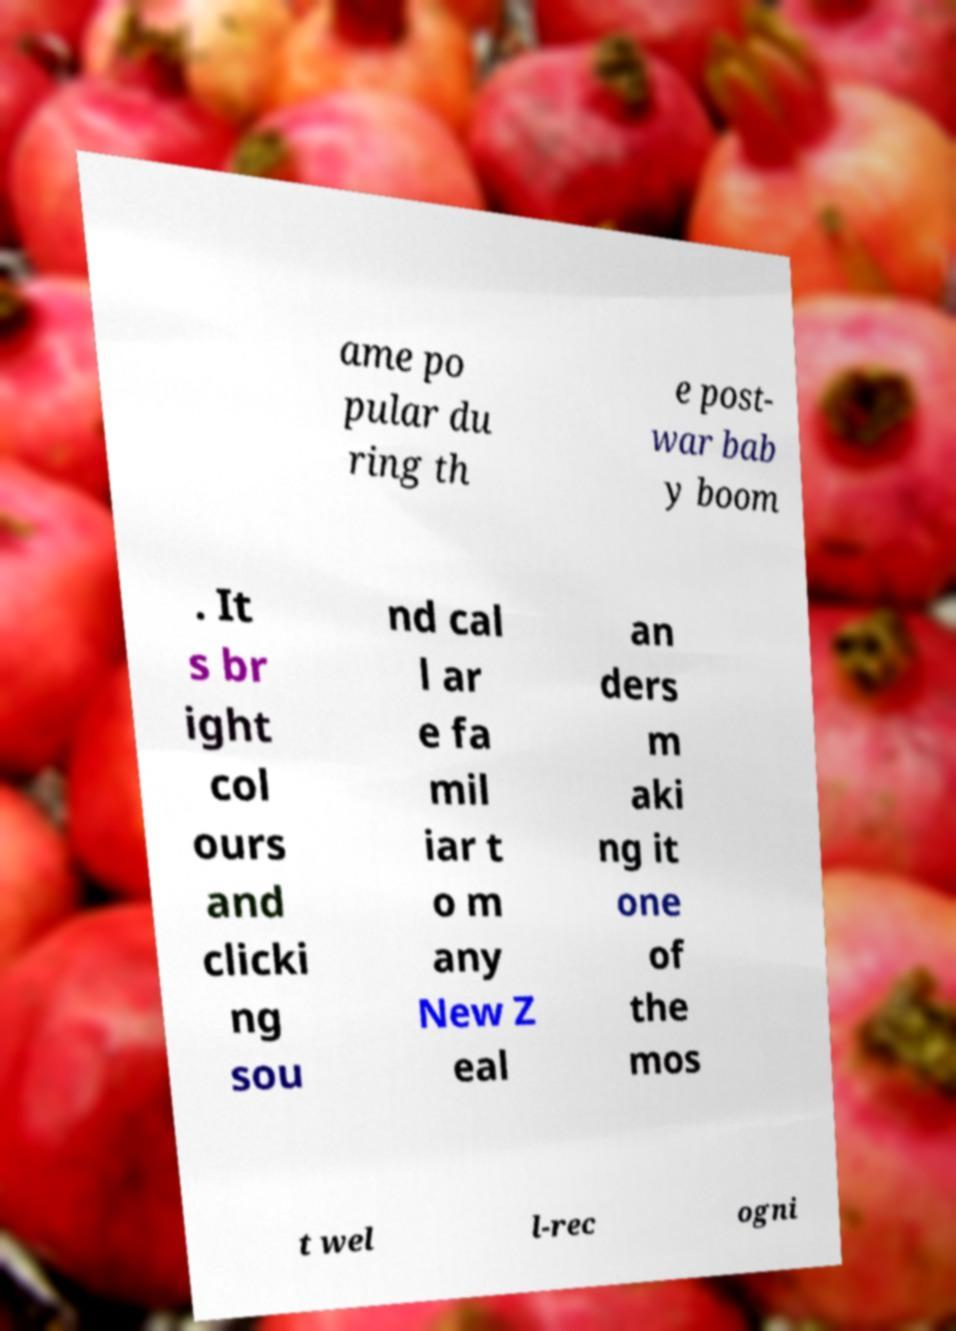Can you accurately transcribe the text from the provided image for me? ame po pular du ring th e post- war bab y boom . It s br ight col ours and clicki ng sou nd cal l ar e fa mil iar t o m any New Z eal an ders m aki ng it one of the mos t wel l-rec ogni 